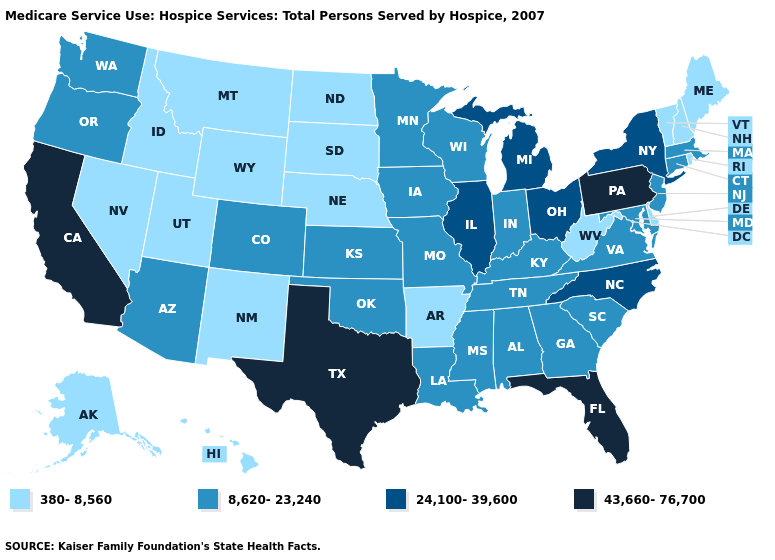What is the highest value in the South ?
Concise answer only. 43,660-76,700. What is the highest value in states that border New Jersey?
Be succinct. 43,660-76,700. Does Pennsylvania have the lowest value in the USA?
Quick response, please. No. Does the first symbol in the legend represent the smallest category?
Quick response, please. Yes. Does Washington have the lowest value in the West?
Give a very brief answer. No. Among the states that border North Dakota , does Minnesota have the highest value?
Quick response, please. Yes. Which states have the lowest value in the USA?
Answer briefly. Alaska, Arkansas, Delaware, Hawaii, Idaho, Maine, Montana, Nebraska, Nevada, New Hampshire, New Mexico, North Dakota, Rhode Island, South Dakota, Utah, Vermont, West Virginia, Wyoming. What is the value of Wisconsin?
Concise answer only. 8,620-23,240. What is the value of Virginia?
Concise answer only. 8,620-23,240. Does Nebraska have the lowest value in the MidWest?
Keep it brief. Yes. Name the states that have a value in the range 24,100-39,600?
Keep it brief. Illinois, Michigan, New York, North Carolina, Ohio. Name the states that have a value in the range 8,620-23,240?
Write a very short answer. Alabama, Arizona, Colorado, Connecticut, Georgia, Indiana, Iowa, Kansas, Kentucky, Louisiana, Maryland, Massachusetts, Minnesota, Mississippi, Missouri, New Jersey, Oklahoma, Oregon, South Carolina, Tennessee, Virginia, Washington, Wisconsin. Does California have the lowest value in the USA?
Concise answer only. No. Which states have the lowest value in the USA?
Give a very brief answer. Alaska, Arkansas, Delaware, Hawaii, Idaho, Maine, Montana, Nebraska, Nevada, New Hampshire, New Mexico, North Dakota, Rhode Island, South Dakota, Utah, Vermont, West Virginia, Wyoming. Does Minnesota have the highest value in the USA?
Give a very brief answer. No. 